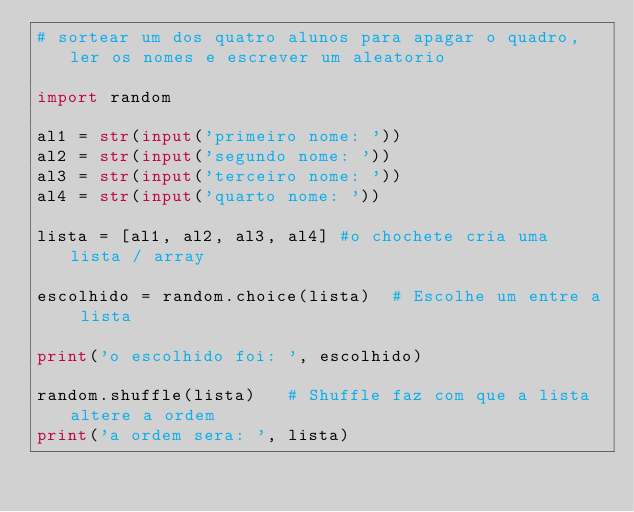<code> <loc_0><loc_0><loc_500><loc_500><_Python_># sortear um dos quatro alunos para apagar o quadro, ler os nomes e escrever um aleatorio

import random

al1 = str(input('primeiro nome: '))
al2 = str(input('segundo nome: '))
al3 = str(input('terceiro nome: '))
al4 = str(input('quarto nome: '))

lista = [al1, al2, al3, al4] #o chochete cria uma lista / array

escolhido = random.choice(lista)  # Escolhe um entre a lista

print('o escolhido foi: ', escolhido)

random.shuffle(lista)   # Shuffle faz com que a lista altere a ordem
print('a ordem sera: ', lista)




</code> 